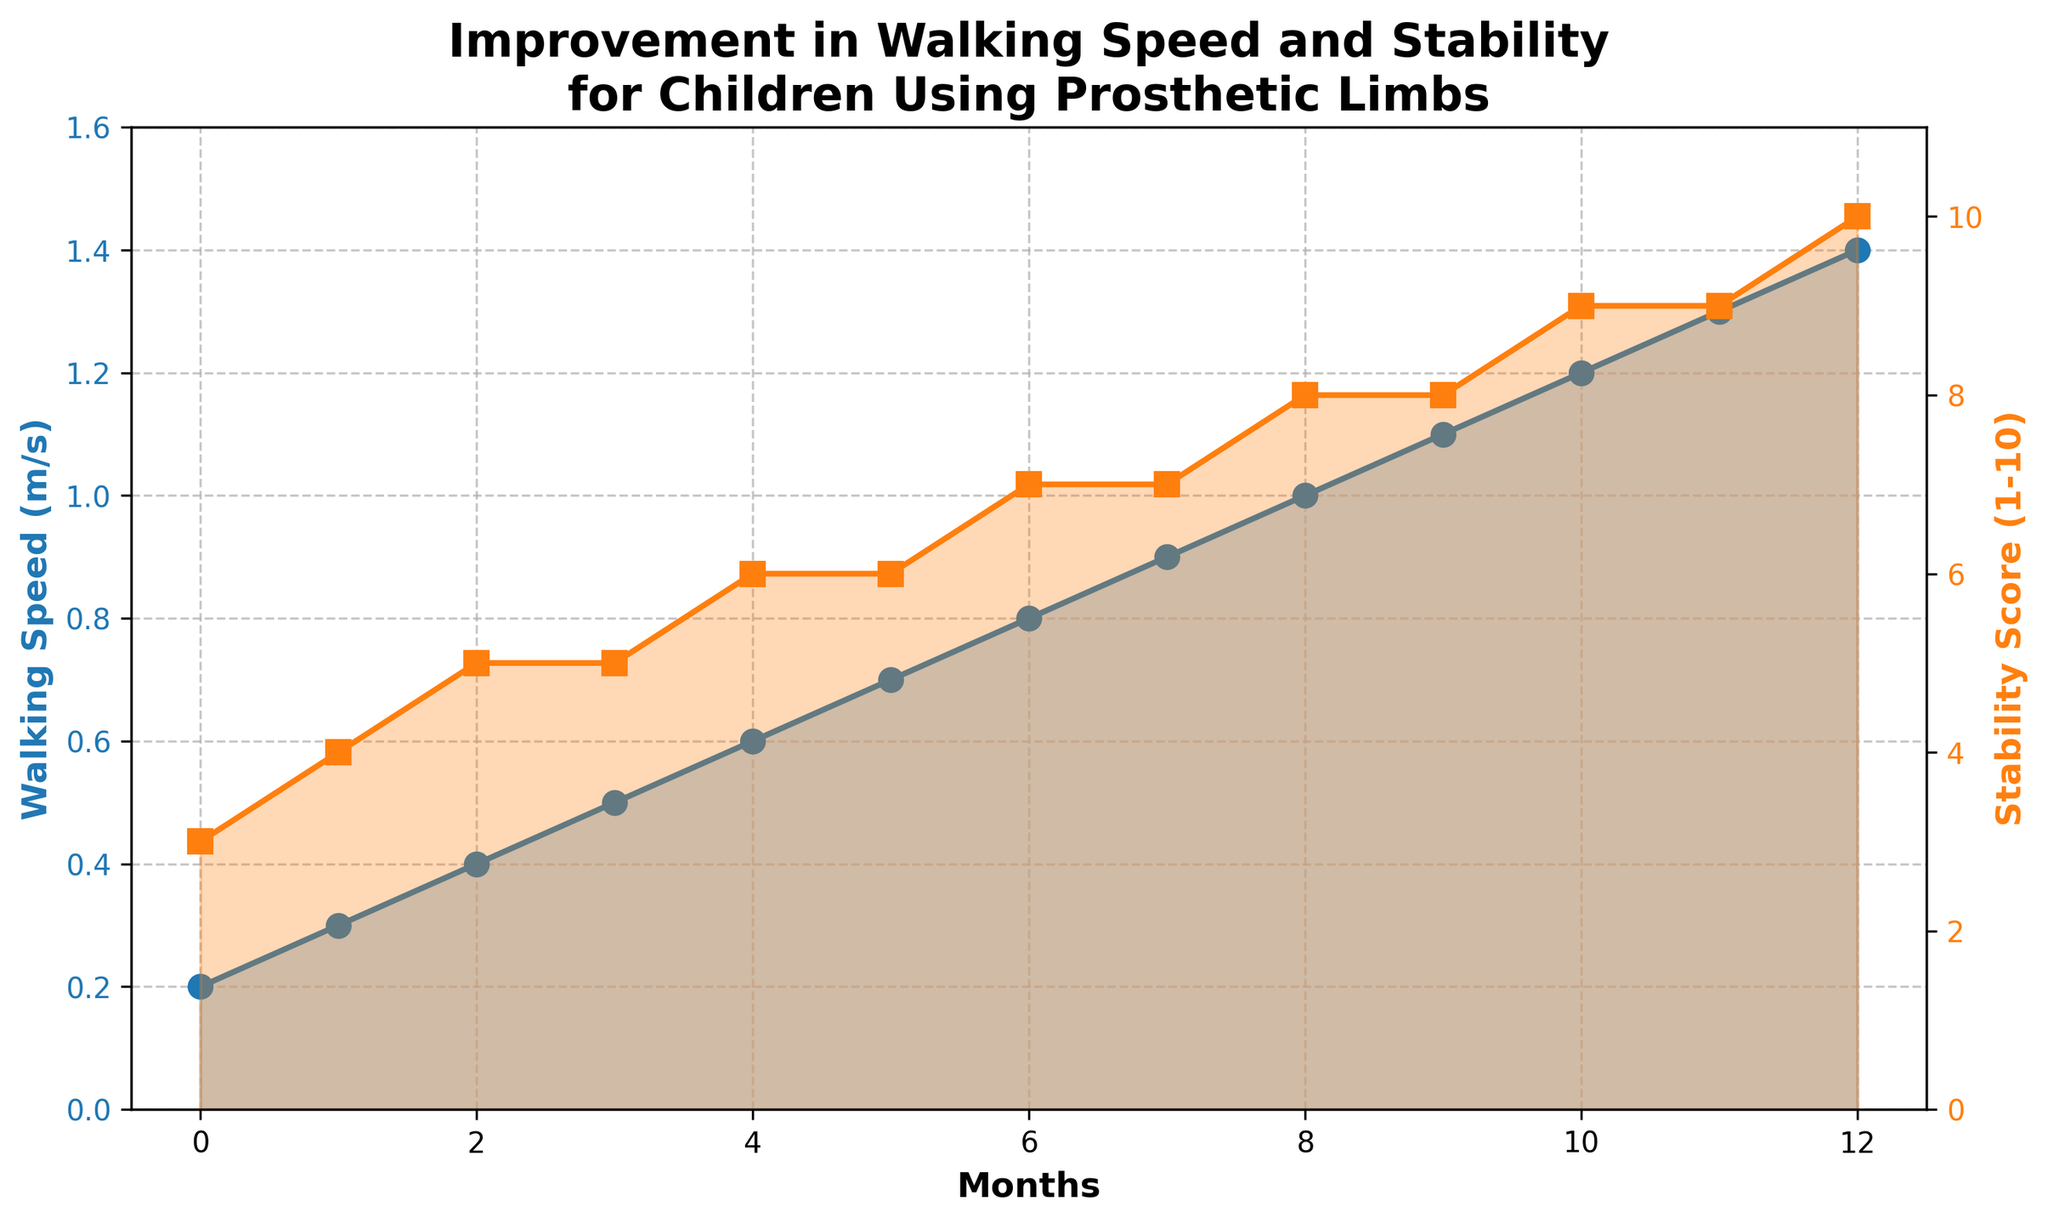What is the walking speed at 6 months? To find the walking speed at 6 months, locate 6 on the x-axis (Months). The corresponding value on the y-axis (Walking Speed) is 0.8 m/s.
Answer: 0.8 m/s How does the stability score change from 3 to 7 months? Locate months 3 and 7 on the x-axis. The stability score at 3 months is 5, and at 7 months it is 7. Subtract 5 from 7 to find the change: 7 - 5 = 2.
Answer: 2 At which month does the walking speed reach 1.0 m/s? Find the month on the x-axis where the y-axis value (Walking Speed) reaches 1.0 m/s. This occurs at month 8.
Answer: 8 Which month shows the highest stability score and what is the value? Look for the peak stability score on the y-axis corresponding to the given months. The highest score of 10 occurs at 12 months.
Answer: 12, 10 Compare the walking speed at month 0 and month 12. How much has it increased? Find the walking speeds at month 0 (0.2 m/s) and month 12 (1.4 m/s). Subtract the initial value from the final value: 1.4 - 0.2 = 1.2 m/s.
Answer: 1.2 m/s What average walking speed is observed from month 0 to month 4? Sum the walking speeds from months 0 to 4 (0.2, 0.3, 0.4, 0.5, 0.6), which totals 2.0 m/s. Divide by the number of months: 2.0 / 5 = 0.4 m/s.
Answer: 0.4 m/s Is the stability score greater than 7 before month 8? If yes, in which month? Check stability scores for months before 8. The score exceeds 7 at months 10 and 11, being exactly 9.
Answer: 10, 11 Which line in the graph uses a blue color? The blue line represents the walking speed as noted by its color and corresponding y-axis label.
Answer: Walking speed Calculate the total increase in stability score from month 0 to month 12. Stability scores at month 0 and month 12 are 3 and 10, respectively. Subtract the initial value from the final value: 10 - 3 = 7.
Answer: 7 Compare the trends of walking speed and stability score over the year. Do both metrics rise consistently? Both walking speed and stability score steadily increase month by month, without any declines. The trends show consistent improvement.
Answer: Yes 